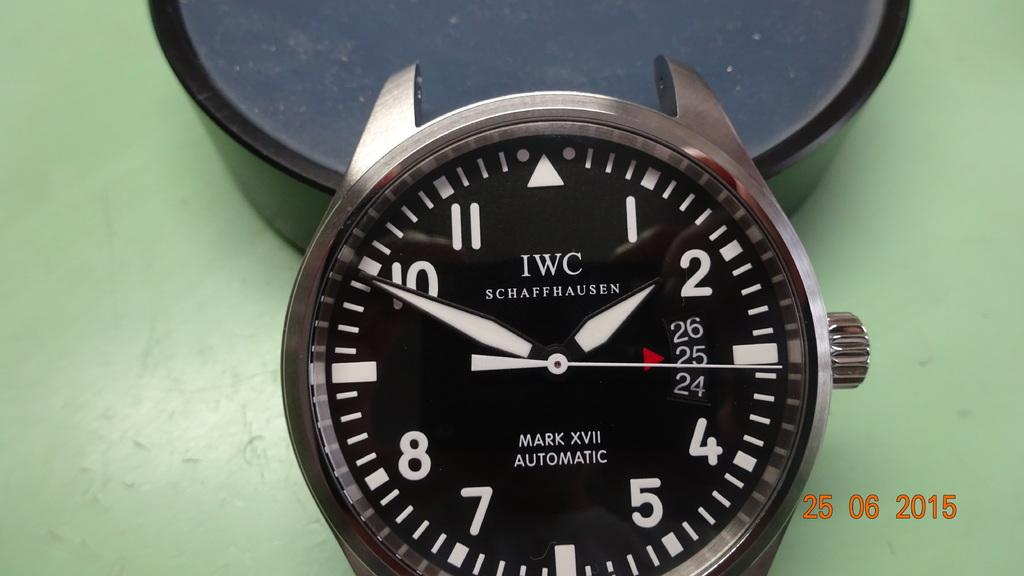<image>
Write a terse but informative summary of the picture. a IWC watch head that is black and silver. 